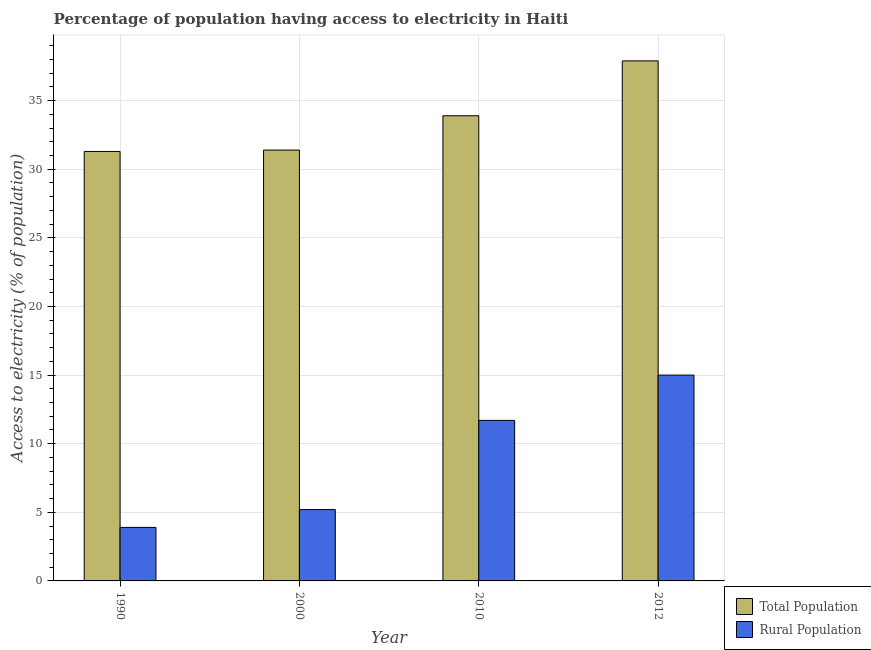How many groups of bars are there?
Give a very brief answer. 4. Are the number of bars on each tick of the X-axis equal?
Provide a succinct answer. Yes. Across all years, what is the maximum percentage of population having access to electricity?
Give a very brief answer. 37.9. In which year was the percentage of population having access to electricity maximum?
Keep it short and to the point. 2012. What is the total percentage of rural population having access to electricity in the graph?
Provide a succinct answer. 35.8. What is the difference between the percentage of rural population having access to electricity in 2010 and that in 2012?
Make the answer very short. -3.3. What is the difference between the percentage of population having access to electricity in 1990 and the percentage of rural population having access to electricity in 2000?
Your answer should be very brief. -0.1. What is the average percentage of rural population having access to electricity per year?
Your answer should be very brief. 8.95. In the year 1990, what is the difference between the percentage of population having access to electricity and percentage of rural population having access to electricity?
Provide a succinct answer. 0. In how many years, is the percentage of population having access to electricity greater than 3 %?
Offer a terse response. 4. What is the ratio of the percentage of rural population having access to electricity in 2000 to that in 2010?
Offer a very short reply. 0.44. Is the percentage of rural population having access to electricity in 1990 less than that in 2000?
Offer a terse response. Yes. What is the difference between the highest and the second highest percentage of rural population having access to electricity?
Offer a very short reply. 3.3. What is the difference between the highest and the lowest percentage of population having access to electricity?
Keep it short and to the point. 6.6. In how many years, is the percentage of population having access to electricity greater than the average percentage of population having access to electricity taken over all years?
Ensure brevity in your answer.  2. Is the sum of the percentage of rural population having access to electricity in 1990 and 2000 greater than the maximum percentage of population having access to electricity across all years?
Offer a very short reply. No. What does the 1st bar from the left in 2010 represents?
Your answer should be compact. Total Population. What does the 2nd bar from the right in 1990 represents?
Give a very brief answer. Total Population. How many bars are there?
Your answer should be compact. 8. Does the graph contain any zero values?
Provide a succinct answer. No. Does the graph contain grids?
Your answer should be very brief. Yes. Where does the legend appear in the graph?
Offer a terse response. Bottom right. How are the legend labels stacked?
Provide a short and direct response. Vertical. What is the title of the graph?
Offer a very short reply. Percentage of population having access to electricity in Haiti. Does "Automatic Teller Machines" appear as one of the legend labels in the graph?
Ensure brevity in your answer.  No. What is the label or title of the Y-axis?
Your response must be concise. Access to electricity (% of population). What is the Access to electricity (% of population) in Total Population in 1990?
Provide a short and direct response. 31.3. What is the Access to electricity (% of population) in Total Population in 2000?
Your response must be concise. 31.4. What is the Access to electricity (% of population) in Total Population in 2010?
Keep it short and to the point. 33.9. What is the Access to electricity (% of population) in Rural Population in 2010?
Make the answer very short. 11.7. What is the Access to electricity (% of population) of Total Population in 2012?
Ensure brevity in your answer.  37.9. Across all years, what is the maximum Access to electricity (% of population) in Total Population?
Your response must be concise. 37.9. Across all years, what is the minimum Access to electricity (% of population) in Total Population?
Your response must be concise. 31.3. Across all years, what is the minimum Access to electricity (% of population) of Rural Population?
Give a very brief answer. 3.9. What is the total Access to electricity (% of population) in Total Population in the graph?
Your response must be concise. 134.5. What is the total Access to electricity (% of population) in Rural Population in the graph?
Offer a very short reply. 35.8. What is the difference between the Access to electricity (% of population) in Rural Population in 1990 and that in 2000?
Provide a short and direct response. -1.3. What is the difference between the Access to electricity (% of population) in Total Population in 1990 and that in 2010?
Ensure brevity in your answer.  -2.6. What is the difference between the Access to electricity (% of population) in Rural Population in 1990 and that in 2010?
Give a very brief answer. -7.8. What is the difference between the Access to electricity (% of population) in Rural Population in 1990 and that in 2012?
Your response must be concise. -11.1. What is the difference between the Access to electricity (% of population) of Total Population in 2000 and that in 2010?
Your answer should be compact. -2.5. What is the difference between the Access to electricity (% of population) of Rural Population in 2000 and that in 2012?
Offer a very short reply. -9.8. What is the difference between the Access to electricity (% of population) in Total Population in 1990 and the Access to electricity (% of population) in Rural Population in 2000?
Your response must be concise. 26.1. What is the difference between the Access to electricity (% of population) in Total Population in 1990 and the Access to electricity (% of population) in Rural Population in 2010?
Your response must be concise. 19.6. What is the difference between the Access to electricity (% of population) of Total Population in 2000 and the Access to electricity (% of population) of Rural Population in 2010?
Ensure brevity in your answer.  19.7. What is the average Access to electricity (% of population) of Total Population per year?
Provide a succinct answer. 33.62. What is the average Access to electricity (% of population) in Rural Population per year?
Provide a short and direct response. 8.95. In the year 1990, what is the difference between the Access to electricity (% of population) in Total Population and Access to electricity (% of population) in Rural Population?
Provide a short and direct response. 27.4. In the year 2000, what is the difference between the Access to electricity (% of population) of Total Population and Access to electricity (% of population) of Rural Population?
Offer a terse response. 26.2. In the year 2012, what is the difference between the Access to electricity (% of population) of Total Population and Access to electricity (% of population) of Rural Population?
Your answer should be compact. 22.9. What is the ratio of the Access to electricity (% of population) in Rural Population in 1990 to that in 2000?
Your answer should be very brief. 0.75. What is the ratio of the Access to electricity (% of population) in Total Population in 1990 to that in 2010?
Make the answer very short. 0.92. What is the ratio of the Access to electricity (% of population) of Rural Population in 1990 to that in 2010?
Ensure brevity in your answer.  0.33. What is the ratio of the Access to electricity (% of population) in Total Population in 1990 to that in 2012?
Ensure brevity in your answer.  0.83. What is the ratio of the Access to electricity (% of population) of Rural Population in 1990 to that in 2012?
Give a very brief answer. 0.26. What is the ratio of the Access to electricity (% of population) in Total Population in 2000 to that in 2010?
Your response must be concise. 0.93. What is the ratio of the Access to electricity (% of population) of Rural Population in 2000 to that in 2010?
Ensure brevity in your answer.  0.44. What is the ratio of the Access to electricity (% of population) in Total Population in 2000 to that in 2012?
Your answer should be very brief. 0.83. What is the ratio of the Access to electricity (% of population) of Rural Population in 2000 to that in 2012?
Your response must be concise. 0.35. What is the ratio of the Access to electricity (% of population) in Total Population in 2010 to that in 2012?
Offer a very short reply. 0.89. What is the ratio of the Access to electricity (% of population) of Rural Population in 2010 to that in 2012?
Make the answer very short. 0.78. What is the difference between the highest and the second highest Access to electricity (% of population) in Rural Population?
Keep it short and to the point. 3.3. What is the difference between the highest and the lowest Access to electricity (% of population) in Total Population?
Keep it short and to the point. 6.6. 